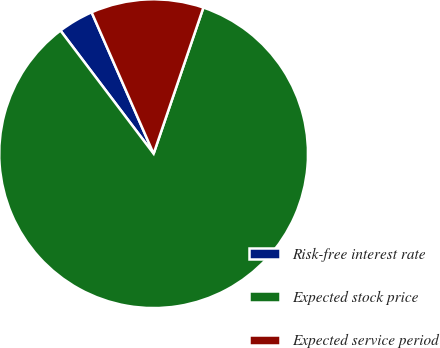Convert chart to OTSL. <chart><loc_0><loc_0><loc_500><loc_500><pie_chart><fcel>Risk-free interest rate<fcel>Expected stock price<fcel>Expected service period<nl><fcel>3.73%<fcel>84.47%<fcel>11.8%<nl></chart> 